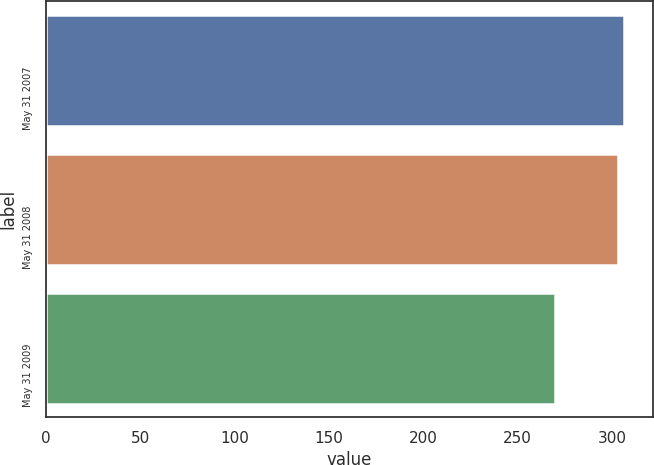<chart> <loc_0><loc_0><loc_500><loc_500><bar_chart><fcel>May 31 2007<fcel>May 31 2008<fcel>May 31 2009<nl><fcel>306.6<fcel>303<fcel>270<nl></chart> 